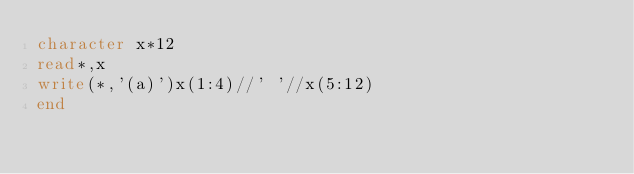<code> <loc_0><loc_0><loc_500><loc_500><_FORTRAN_>character x*12
read*,x
write(*,'(a)')x(1:4)//' '//x(5:12)
end</code> 